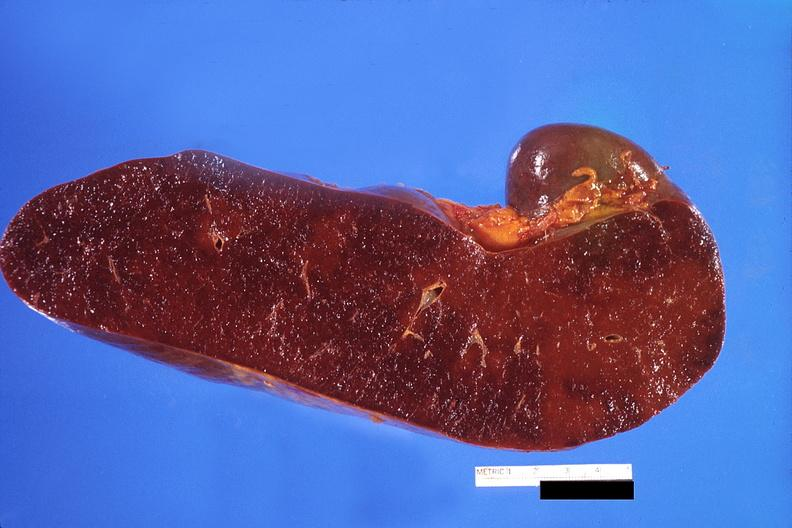what does this image show?
Answer the question using a single word or phrase. Spleen 